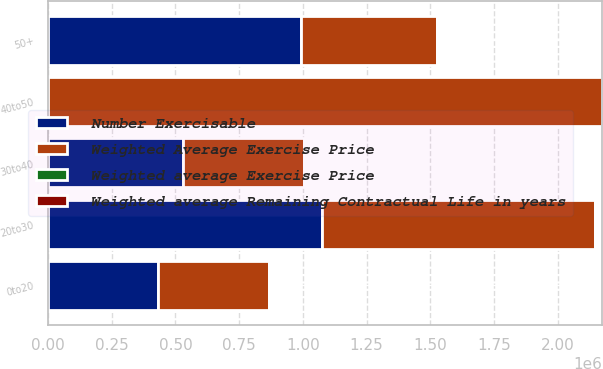<chart> <loc_0><loc_0><loc_500><loc_500><stacked_bar_chart><ecel><fcel>0to20<fcel>20to30<fcel>30to40<fcel>40to50<fcel>50+<nl><fcel>Number Exercisable<fcel>432631<fcel>1.07433e+06<fcel>528961<fcel>57.65<fcel>994402<nl><fcel>Weighted average Remaining Contractual Life in years<fcel>1.6<fcel>4.1<fcel>7.3<fcel>7.5<fcel>8.2<nl><fcel>Weighted average Exercise Price<fcel>18.67<fcel>25.83<fcel>38.05<fcel>44.6<fcel>57.65<nl><fcel>Weighted Average Exercise Price<fcel>432631<fcel>1.07433e+06<fcel>474295<fcel>2.1748e+06<fcel>531075<nl></chart> 